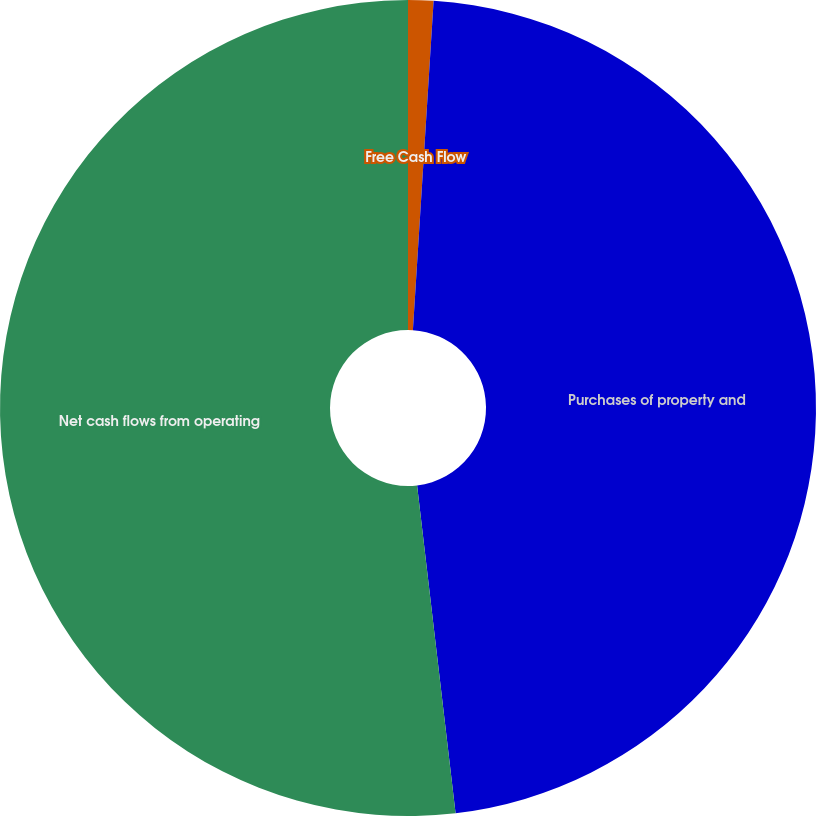Convert chart to OTSL. <chart><loc_0><loc_0><loc_500><loc_500><pie_chart><fcel>Free Cash Flow<fcel>Purchases of property and<fcel>Net cash flows from operating<nl><fcel>1.0%<fcel>47.14%<fcel>51.86%<nl></chart> 